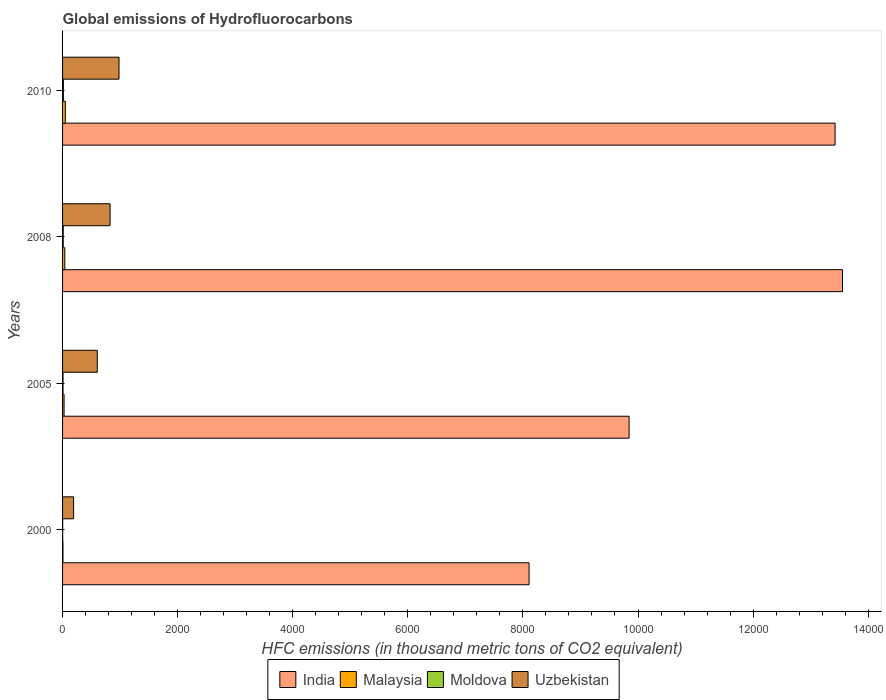How many different coloured bars are there?
Provide a short and direct response. 4. How many groups of bars are there?
Offer a terse response. 4. How many bars are there on the 4th tick from the bottom?
Offer a terse response. 4. What is the label of the 3rd group of bars from the top?
Your response must be concise. 2005. In how many cases, is the number of bars for a given year not equal to the number of legend labels?
Make the answer very short. 0. Across all years, what is the maximum global emissions of Hydrofluorocarbons in Malaysia?
Your response must be concise. 48. Across all years, what is the minimum global emissions of Hydrofluorocarbons in Malaysia?
Offer a very short reply. 6.9. In which year was the global emissions of Hydrofluorocarbons in India minimum?
Your response must be concise. 2000. What is the total global emissions of Hydrofluorocarbons in Moldova in the graph?
Ensure brevity in your answer.  35.2. What is the difference between the global emissions of Hydrofluorocarbons in India in 2005 and the global emissions of Hydrofluorocarbons in Malaysia in 2008?
Provide a succinct answer. 9806. What is the average global emissions of Hydrofluorocarbons in Malaysia per year?
Make the answer very short. 30.05. In the year 2010, what is the difference between the global emissions of Hydrofluorocarbons in Malaysia and global emissions of Hydrofluorocarbons in Uzbekistan?
Ensure brevity in your answer.  -933. In how many years, is the global emissions of Hydrofluorocarbons in India greater than 400 thousand metric tons?
Offer a terse response. 4. What is the ratio of the global emissions of Hydrofluorocarbons in India in 2008 to that in 2010?
Your answer should be compact. 1.01. Is the global emissions of Hydrofluorocarbons in Malaysia in 2008 less than that in 2010?
Keep it short and to the point. Yes. Is the difference between the global emissions of Hydrofluorocarbons in Malaysia in 2000 and 2005 greater than the difference between the global emissions of Hydrofluorocarbons in Uzbekistan in 2000 and 2005?
Offer a very short reply. Yes. What is the difference between the highest and the second highest global emissions of Hydrofluorocarbons in Malaysia?
Provide a short and direct response. 8.8. In how many years, is the global emissions of Hydrofluorocarbons in Malaysia greater than the average global emissions of Hydrofluorocarbons in Malaysia taken over all years?
Keep it short and to the point. 2. Is the sum of the global emissions of Hydrofluorocarbons in Moldova in 2005 and 2010 greater than the maximum global emissions of Hydrofluorocarbons in Malaysia across all years?
Provide a succinct answer. No. What does the 2nd bar from the top in 2008 represents?
Your answer should be compact. Moldova. What does the 3rd bar from the bottom in 2005 represents?
Your answer should be very brief. Moldova. Is it the case that in every year, the sum of the global emissions of Hydrofluorocarbons in Moldova and global emissions of Hydrofluorocarbons in India is greater than the global emissions of Hydrofluorocarbons in Uzbekistan?
Provide a short and direct response. Yes. How many years are there in the graph?
Provide a short and direct response. 4. What is the difference between two consecutive major ticks on the X-axis?
Provide a short and direct response. 2000. Does the graph contain any zero values?
Your answer should be very brief. No. What is the title of the graph?
Offer a very short reply. Global emissions of Hydrofluorocarbons. Does "Spain" appear as one of the legend labels in the graph?
Your response must be concise. No. What is the label or title of the X-axis?
Your answer should be very brief. HFC emissions (in thousand metric tons of CO2 equivalent). What is the label or title of the Y-axis?
Ensure brevity in your answer.  Years. What is the HFC emissions (in thousand metric tons of CO2 equivalent) of India in 2000?
Give a very brief answer. 8107.2. What is the HFC emissions (in thousand metric tons of CO2 equivalent) of Malaysia in 2000?
Your answer should be compact. 6.9. What is the HFC emissions (in thousand metric tons of CO2 equivalent) of Uzbekistan in 2000?
Your response must be concise. 192. What is the HFC emissions (in thousand metric tons of CO2 equivalent) in India in 2005?
Ensure brevity in your answer.  9845.2. What is the HFC emissions (in thousand metric tons of CO2 equivalent) of Malaysia in 2005?
Your response must be concise. 26.1. What is the HFC emissions (in thousand metric tons of CO2 equivalent) of Uzbekistan in 2005?
Keep it short and to the point. 603.2. What is the HFC emissions (in thousand metric tons of CO2 equivalent) of India in 2008?
Give a very brief answer. 1.36e+04. What is the HFC emissions (in thousand metric tons of CO2 equivalent) of Malaysia in 2008?
Provide a succinct answer. 39.2. What is the HFC emissions (in thousand metric tons of CO2 equivalent) of Moldova in 2008?
Make the answer very short. 11.3. What is the HFC emissions (in thousand metric tons of CO2 equivalent) of Uzbekistan in 2008?
Offer a very short reply. 825.6. What is the HFC emissions (in thousand metric tons of CO2 equivalent) of India in 2010?
Keep it short and to the point. 1.34e+04. What is the HFC emissions (in thousand metric tons of CO2 equivalent) of Malaysia in 2010?
Your response must be concise. 48. What is the HFC emissions (in thousand metric tons of CO2 equivalent) of Moldova in 2010?
Offer a very short reply. 14. What is the HFC emissions (in thousand metric tons of CO2 equivalent) of Uzbekistan in 2010?
Offer a very short reply. 981. Across all years, what is the maximum HFC emissions (in thousand metric tons of CO2 equivalent) of India?
Give a very brief answer. 1.36e+04. Across all years, what is the maximum HFC emissions (in thousand metric tons of CO2 equivalent) of Malaysia?
Provide a succinct answer. 48. Across all years, what is the maximum HFC emissions (in thousand metric tons of CO2 equivalent) of Uzbekistan?
Keep it short and to the point. 981. Across all years, what is the minimum HFC emissions (in thousand metric tons of CO2 equivalent) of India?
Provide a short and direct response. 8107.2. Across all years, what is the minimum HFC emissions (in thousand metric tons of CO2 equivalent) of Moldova?
Offer a very short reply. 1.9. Across all years, what is the minimum HFC emissions (in thousand metric tons of CO2 equivalent) of Uzbekistan?
Keep it short and to the point. 192. What is the total HFC emissions (in thousand metric tons of CO2 equivalent) in India in the graph?
Your answer should be very brief. 4.49e+04. What is the total HFC emissions (in thousand metric tons of CO2 equivalent) in Malaysia in the graph?
Your answer should be compact. 120.2. What is the total HFC emissions (in thousand metric tons of CO2 equivalent) in Moldova in the graph?
Your answer should be very brief. 35.2. What is the total HFC emissions (in thousand metric tons of CO2 equivalent) in Uzbekistan in the graph?
Ensure brevity in your answer.  2601.8. What is the difference between the HFC emissions (in thousand metric tons of CO2 equivalent) of India in 2000 and that in 2005?
Give a very brief answer. -1738. What is the difference between the HFC emissions (in thousand metric tons of CO2 equivalent) of Malaysia in 2000 and that in 2005?
Offer a very short reply. -19.2. What is the difference between the HFC emissions (in thousand metric tons of CO2 equivalent) in Moldova in 2000 and that in 2005?
Make the answer very short. -6.1. What is the difference between the HFC emissions (in thousand metric tons of CO2 equivalent) in Uzbekistan in 2000 and that in 2005?
Offer a very short reply. -411.2. What is the difference between the HFC emissions (in thousand metric tons of CO2 equivalent) of India in 2000 and that in 2008?
Your response must be concise. -5446.5. What is the difference between the HFC emissions (in thousand metric tons of CO2 equivalent) in Malaysia in 2000 and that in 2008?
Your answer should be compact. -32.3. What is the difference between the HFC emissions (in thousand metric tons of CO2 equivalent) in Uzbekistan in 2000 and that in 2008?
Offer a very short reply. -633.6. What is the difference between the HFC emissions (in thousand metric tons of CO2 equivalent) in India in 2000 and that in 2010?
Your answer should be very brief. -5317.8. What is the difference between the HFC emissions (in thousand metric tons of CO2 equivalent) in Malaysia in 2000 and that in 2010?
Provide a short and direct response. -41.1. What is the difference between the HFC emissions (in thousand metric tons of CO2 equivalent) of Uzbekistan in 2000 and that in 2010?
Your response must be concise. -789. What is the difference between the HFC emissions (in thousand metric tons of CO2 equivalent) in India in 2005 and that in 2008?
Offer a very short reply. -3708.5. What is the difference between the HFC emissions (in thousand metric tons of CO2 equivalent) in Uzbekistan in 2005 and that in 2008?
Provide a succinct answer. -222.4. What is the difference between the HFC emissions (in thousand metric tons of CO2 equivalent) of India in 2005 and that in 2010?
Provide a succinct answer. -3579.8. What is the difference between the HFC emissions (in thousand metric tons of CO2 equivalent) in Malaysia in 2005 and that in 2010?
Your response must be concise. -21.9. What is the difference between the HFC emissions (in thousand metric tons of CO2 equivalent) of Moldova in 2005 and that in 2010?
Your answer should be very brief. -6. What is the difference between the HFC emissions (in thousand metric tons of CO2 equivalent) in Uzbekistan in 2005 and that in 2010?
Ensure brevity in your answer.  -377.8. What is the difference between the HFC emissions (in thousand metric tons of CO2 equivalent) in India in 2008 and that in 2010?
Your response must be concise. 128.7. What is the difference between the HFC emissions (in thousand metric tons of CO2 equivalent) of Uzbekistan in 2008 and that in 2010?
Provide a short and direct response. -155.4. What is the difference between the HFC emissions (in thousand metric tons of CO2 equivalent) of India in 2000 and the HFC emissions (in thousand metric tons of CO2 equivalent) of Malaysia in 2005?
Offer a terse response. 8081.1. What is the difference between the HFC emissions (in thousand metric tons of CO2 equivalent) of India in 2000 and the HFC emissions (in thousand metric tons of CO2 equivalent) of Moldova in 2005?
Your response must be concise. 8099.2. What is the difference between the HFC emissions (in thousand metric tons of CO2 equivalent) in India in 2000 and the HFC emissions (in thousand metric tons of CO2 equivalent) in Uzbekistan in 2005?
Your answer should be very brief. 7504. What is the difference between the HFC emissions (in thousand metric tons of CO2 equivalent) in Malaysia in 2000 and the HFC emissions (in thousand metric tons of CO2 equivalent) in Uzbekistan in 2005?
Make the answer very short. -596.3. What is the difference between the HFC emissions (in thousand metric tons of CO2 equivalent) of Moldova in 2000 and the HFC emissions (in thousand metric tons of CO2 equivalent) of Uzbekistan in 2005?
Your answer should be compact. -601.3. What is the difference between the HFC emissions (in thousand metric tons of CO2 equivalent) of India in 2000 and the HFC emissions (in thousand metric tons of CO2 equivalent) of Malaysia in 2008?
Keep it short and to the point. 8068. What is the difference between the HFC emissions (in thousand metric tons of CO2 equivalent) in India in 2000 and the HFC emissions (in thousand metric tons of CO2 equivalent) in Moldova in 2008?
Your answer should be very brief. 8095.9. What is the difference between the HFC emissions (in thousand metric tons of CO2 equivalent) of India in 2000 and the HFC emissions (in thousand metric tons of CO2 equivalent) of Uzbekistan in 2008?
Make the answer very short. 7281.6. What is the difference between the HFC emissions (in thousand metric tons of CO2 equivalent) of Malaysia in 2000 and the HFC emissions (in thousand metric tons of CO2 equivalent) of Moldova in 2008?
Offer a terse response. -4.4. What is the difference between the HFC emissions (in thousand metric tons of CO2 equivalent) in Malaysia in 2000 and the HFC emissions (in thousand metric tons of CO2 equivalent) in Uzbekistan in 2008?
Your response must be concise. -818.7. What is the difference between the HFC emissions (in thousand metric tons of CO2 equivalent) in Moldova in 2000 and the HFC emissions (in thousand metric tons of CO2 equivalent) in Uzbekistan in 2008?
Your response must be concise. -823.7. What is the difference between the HFC emissions (in thousand metric tons of CO2 equivalent) in India in 2000 and the HFC emissions (in thousand metric tons of CO2 equivalent) in Malaysia in 2010?
Ensure brevity in your answer.  8059.2. What is the difference between the HFC emissions (in thousand metric tons of CO2 equivalent) in India in 2000 and the HFC emissions (in thousand metric tons of CO2 equivalent) in Moldova in 2010?
Your answer should be very brief. 8093.2. What is the difference between the HFC emissions (in thousand metric tons of CO2 equivalent) in India in 2000 and the HFC emissions (in thousand metric tons of CO2 equivalent) in Uzbekistan in 2010?
Provide a short and direct response. 7126.2. What is the difference between the HFC emissions (in thousand metric tons of CO2 equivalent) of Malaysia in 2000 and the HFC emissions (in thousand metric tons of CO2 equivalent) of Uzbekistan in 2010?
Provide a succinct answer. -974.1. What is the difference between the HFC emissions (in thousand metric tons of CO2 equivalent) in Moldova in 2000 and the HFC emissions (in thousand metric tons of CO2 equivalent) in Uzbekistan in 2010?
Your answer should be compact. -979.1. What is the difference between the HFC emissions (in thousand metric tons of CO2 equivalent) of India in 2005 and the HFC emissions (in thousand metric tons of CO2 equivalent) of Malaysia in 2008?
Offer a very short reply. 9806. What is the difference between the HFC emissions (in thousand metric tons of CO2 equivalent) of India in 2005 and the HFC emissions (in thousand metric tons of CO2 equivalent) of Moldova in 2008?
Make the answer very short. 9833.9. What is the difference between the HFC emissions (in thousand metric tons of CO2 equivalent) of India in 2005 and the HFC emissions (in thousand metric tons of CO2 equivalent) of Uzbekistan in 2008?
Offer a terse response. 9019.6. What is the difference between the HFC emissions (in thousand metric tons of CO2 equivalent) of Malaysia in 2005 and the HFC emissions (in thousand metric tons of CO2 equivalent) of Moldova in 2008?
Offer a terse response. 14.8. What is the difference between the HFC emissions (in thousand metric tons of CO2 equivalent) in Malaysia in 2005 and the HFC emissions (in thousand metric tons of CO2 equivalent) in Uzbekistan in 2008?
Provide a short and direct response. -799.5. What is the difference between the HFC emissions (in thousand metric tons of CO2 equivalent) in Moldova in 2005 and the HFC emissions (in thousand metric tons of CO2 equivalent) in Uzbekistan in 2008?
Offer a very short reply. -817.6. What is the difference between the HFC emissions (in thousand metric tons of CO2 equivalent) of India in 2005 and the HFC emissions (in thousand metric tons of CO2 equivalent) of Malaysia in 2010?
Offer a terse response. 9797.2. What is the difference between the HFC emissions (in thousand metric tons of CO2 equivalent) in India in 2005 and the HFC emissions (in thousand metric tons of CO2 equivalent) in Moldova in 2010?
Provide a succinct answer. 9831.2. What is the difference between the HFC emissions (in thousand metric tons of CO2 equivalent) of India in 2005 and the HFC emissions (in thousand metric tons of CO2 equivalent) of Uzbekistan in 2010?
Your answer should be compact. 8864.2. What is the difference between the HFC emissions (in thousand metric tons of CO2 equivalent) in Malaysia in 2005 and the HFC emissions (in thousand metric tons of CO2 equivalent) in Moldova in 2010?
Your response must be concise. 12.1. What is the difference between the HFC emissions (in thousand metric tons of CO2 equivalent) of Malaysia in 2005 and the HFC emissions (in thousand metric tons of CO2 equivalent) of Uzbekistan in 2010?
Your response must be concise. -954.9. What is the difference between the HFC emissions (in thousand metric tons of CO2 equivalent) of Moldova in 2005 and the HFC emissions (in thousand metric tons of CO2 equivalent) of Uzbekistan in 2010?
Keep it short and to the point. -973. What is the difference between the HFC emissions (in thousand metric tons of CO2 equivalent) in India in 2008 and the HFC emissions (in thousand metric tons of CO2 equivalent) in Malaysia in 2010?
Give a very brief answer. 1.35e+04. What is the difference between the HFC emissions (in thousand metric tons of CO2 equivalent) in India in 2008 and the HFC emissions (in thousand metric tons of CO2 equivalent) in Moldova in 2010?
Your answer should be compact. 1.35e+04. What is the difference between the HFC emissions (in thousand metric tons of CO2 equivalent) of India in 2008 and the HFC emissions (in thousand metric tons of CO2 equivalent) of Uzbekistan in 2010?
Make the answer very short. 1.26e+04. What is the difference between the HFC emissions (in thousand metric tons of CO2 equivalent) in Malaysia in 2008 and the HFC emissions (in thousand metric tons of CO2 equivalent) in Moldova in 2010?
Your answer should be very brief. 25.2. What is the difference between the HFC emissions (in thousand metric tons of CO2 equivalent) in Malaysia in 2008 and the HFC emissions (in thousand metric tons of CO2 equivalent) in Uzbekistan in 2010?
Ensure brevity in your answer.  -941.8. What is the difference between the HFC emissions (in thousand metric tons of CO2 equivalent) in Moldova in 2008 and the HFC emissions (in thousand metric tons of CO2 equivalent) in Uzbekistan in 2010?
Provide a short and direct response. -969.7. What is the average HFC emissions (in thousand metric tons of CO2 equivalent) of India per year?
Keep it short and to the point. 1.12e+04. What is the average HFC emissions (in thousand metric tons of CO2 equivalent) in Malaysia per year?
Your answer should be very brief. 30.05. What is the average HFC emissions (in thousand metric tons of CO2 equivalent) in Moldova per year?
Your response must be concise. 8.8. What is the average HFC emissions (in thousand metric tons of CO2 equivalent) in Uzbekistan per year?
Your answer should be compact. 650.45. In the year 2000, what is the difference between the HFC emissions (in thousand metric tons of CO2 equivalent) in India and HFC emissions (in thousand metric tons of CO2 equivalent) in Malaysia?
Make the answer very short. 8100.3. In the year 2000, what is the difference between the HFC emissions (in thousand metric tons of CO2 equivalent) in India and HFC emissions (in thousand metric tons of CO2 equivalent) in Moldova?
Your answer should be very brief. 8105.3. In the year 2000, what is the difference between the HFC emissions (in thousand metric tons of CO2 equivalent) in India and HFC emissions (in thousand metric tons of CO2 equivalent) in Uzbekistan?
Keep it short and to the point. 7915.2. In the year 2000, what is the difference between the HFC emissions (in thousand metric tons of CO2 equivalent) in Malaysia and HFC emissions (in thousand metric tons of CO2 equivalent) in Moldova?
Ensure brevity in your answer.  5. In the year 2000, what is the difference between the HFC emissions (in thousand metric tons of CO2 equivalent) in Malaysia and HFC emissions (in thousand metric tons of CO2 equivalent) in Uzbekistan?
Offer a terse response. -185.1. In the year 2000, what is the difference between the HFC emissions (in thousand metric tons of CO2 equivalent) of Moldova and HFC emissions (in thousand metric tons of CO2 equivalent) of Uzbekistan?
Provide a succinct answer. -190.1. In the year 2005, what is the difference between the HFC emissions (in thousand metric tons of CO2 equivalent) in India and HFC emissions (in thousand metric tons of CO2 equivalent) in Malaysia?
Your answer should be compact. 9819.1. In the year 2005, what is the difference between the HFC emissions (in thousand metric tons of CO2 equivalent) of India and HFC emissions (in thousand metric tons of CO2 equivalent) of Moldova?
Give a very brief answer. 9837.2. In the year 2005, what is the difference between the HFC emissions (in thousand metric tons of CO2 equivalent) in India and HFC emissions (in thousand metric tons of CO2 equivalent) in Uzbekistan?
Provide a short and direct response. 9242. In the year 2005, what is the difference between the HFC emissions (in thousand metric tons of CO2 equivalent) of Malaysia and HFC emissions (in thousand metric tons of CO2 equivalent) of Uzbekistan?
Make the answer very short. -577.1. In the year 2005, what is the difference between the HFC emissions (in thousand metric tons of CO2 equivalent) in Moldova and HFC emissions (in thousand metric tons of CO2 equivalent) in Uzbekistan?
Provide a short and direct response. -595.2. In the year 2008, what is the difference between the HFC emissions (in thousand metric tons of CO2 equivalent) in India and HFC emissions (in thousand metric tons of CO2 equivalent) in Malaysia?
Provide a short and direct response. 1.35e+04. In the year 2008, what is the difference between the HFC emissions (in thousand metric tons of CO2 equivalent) of India and HFC emissions (in thousand metric tons of CO2 equivalent) of Moldova?
Your answer should be compact. 1.35e+04. In the year 2008, what is the difference between the HFC emissions (in thousand metric tons of CO2 equivalent) of India and HFC emissions (in thousand metric tons of CO2 equivalent) of Uzbekistan?
Your answer should be very brief. 1.27e+04. In the year 2008, what is the difference between the HFC emissions (in thousand metric tons of CO2 equivalent) of Malaysia and HFC emissions (in thousand metric tons of CO2 equivalent) of Moldova?
Offer a terse response. 27.9. In the year 2008, what is the difference between the HFC emissions (in thousand metric tons of CO2 equivalent) in Malaysia and HFC emissions (in thousand metric tons of CO2 equivalent) in Uzbekistan?
Your answer should be very brief. -786.4. In the year 2008, what is the difference between the HFC emissions (in thousand metric tons of CO2 equivalent) of Moldova and HFC emissions (in thousand metric tons of CO2 equivalent) of Uzbekistan?
Offer a very short reply. -814.3. In the year 2010, what is the difference between the HFC emissions (in thousand metric tons of CO2 equivalent) in India and HFC emissions (in thousand metric tons of CO2 equivalent) in Malaysia?
Ensure brevity in your answer.  1.34e+04. In the year 2010, what is the difference between the HFC emissions (in thousand metric tons of CO2 equivalent) of India and HFC emissions (in thousand metric tons of CO2 equivalent) of Moldova?
Ensure brevity in your answer.  1.34e+04. In the year 2010, what is the difference between the HFC emissions (in thousand metric tons of CO2 equivalent) of India and HFC emissions (in thousand metric tons of CO2 equivalent) of Uzbekistan?
Keep it short and to the point. 1.24e+04. In the year 2010, what is the difference between the HFC emissions (in thousand metric tons of CO2 equivalent) in Malaysia and HFC emissions (in thousand metric tons of CO2 equivalent) in Uzbekistan?
Give a very brief answer. -933. In the year 2010, what is the difference between the HFC emissions (in thousand metric tons of CO2 equivalent) of Moldova and HFC emissions (in thousand metric tons of CO2 equivalent) of Uzbekistan?
Your answer should be compact. -967. What is the ratio of the HFC emissions (in thousand metric tons of CO2 equivalent) in India in 2000 to that in 2005?
Your response must be concise. 0.82. What is the ratio of the HFC emissions (in thousand metric tons of CO2 equivalent) of Malaysia in 2000 to that in 2005?
Give a very brief answer. 0.26. What is the ratio of the HFC emissions (in thousand metric tons of CO2 equivalent) in Moldova in 2000 to that in 2005?
Your answer should be very brief. 0.24. What is the ratio of the HFC emissions (in thousand metric tons of CO2 equivalent) of Uzbekistan in 2000 to that in 2005?
Make the answer very short. 0.32. What is the ratio of the HFC emissions (in thousand metric tons of CO2 equivalent) in India in 2000 to that in 2008?
Make the answer very short. 0.6. What is the ratio of the HFC emissions (in thousand metric tons of CO2 equivalent) in Malaysia in 2000 to that in 2008?
Offer a terse response. 0.18. What is the ratio of the HFC emissions (in thousand metric tons of CO2 equivalent) of Moldova in 2000 to that in 2008?
Your response must be concise. 0.17. What is the ratio of the HFC emissions (in thousand metric tons of CO2 equivalent) of Uzbekistan in 2000 to that in 2008?
Provide a succinct answer. 0.23. What is the ratio of the HFC emissions (in thousand metric tons of CO2 equivalent) in India in 2000 to that in 2010?
Your answer should be very brief. 0.6. What is the ratio of the HFC emissions (in thousand metric tons of CO2 equivalent) of Malaysia in 2000 to that in 2010?
Your answer should be very brief. 0.14. What is the ratio of the HFC emissions (in thousand metric tons of CO2 equivalent) of Moldova in 2000 to that in 2010?
Your answer should be compact. 0.14. What is the ratio of the HFC emissions (in thousand metric tons of CO2 equivalent) in Uzbekistan in 2000 to that in 2010?
Ensure brevity in your answer.  0.2. What is the ratio of the HFC emissions (in thousand metric tons of CO2 equivalent) in India in 2005 to that in 2008?
Give a very brief answer. 0.73. What is the ratio of the HFC emissions (in thousand metric tons of CO2 equivalent) in Malaysia in 2005 to that in 2008?
Your response must be concise. 0.67. What is the ratio of the HFC emissions (in thousand metric tons of CO2 equivalent) of Moldova in 2005 to that in 2008?
Ensure brevity in your answer.  0.71. What is the ratio of the HFC emissions (in thousand metric tons of CO2 equivalent) of Uzbekistan in 2005 to that in 2008?
Give a very brief answer. 0.73. What is the ratio of the HFC emissions (in thousand metric tons of CO2 equivalent) of India in 2005 to that in 2010?
Offer a very short reply. 0.73. What is the ratio of the HFC emissions (in thousand metric tons of CO2 equivalent) in Malaysia in 2005 to that in 2010?
Your answer should be compact. 0.54. What is the ratio of the HFC emissions (in thousand metric tons of CO2 equivalent) of Uzbekistan in 2005 to that in 2010?
Offer a very short reply. 0.61. What is the ratio of the HFC emissions (in thousand metric tons of CO2 equivalent) in India in 2008 to that in 2010?
Offer a terse response. 1.01. What is the ratio of the HFC emissions (in thousand metric tons of CO2 equivalent) of Malaysia in 2008 to that in 2010?
Your answer should be very brief. 0.82. What is the ratio of the HFC emissions (in thousand metric tons of CO2 equivalent) of Moldova in 2008 to that in 2010?
Give a very brief answer. 0.81. What is the ratio of the HFC emissions (in thousand metric tons of CO2 equivalent) in Uzbekistan in 2008 to that in 2010?
Make the answer very short. 0.84. What is the difference between the highest and the second highest HFC emissions (in thousand metric tons of CO2 equivalent) in India?
Offer a terse response. 128.7. What is the difference between the highest and the second highest HFC emissions (in thousand metric tons of CO2 equivalent) of Uzbekistan?
Give a very brief answer. 155.4. What is the difference between the highest and the lowest HFC emissions (in thousand metric tons of CO2 equivalent) of India?
Offer a very short reply. 5446.5. What is the difference between the highest and the lowest HFC emissions (in thousand metric tons of CO2 equivalent) of Malaysia?
Ensure brevity in your answer.  41.1. What is the difference between the highest and the lowest HFC emissions (in thousand metric tons of CO2 equivalent) of Moldova?
Provide a succinct answer. 12.1. What is the difference between the highest and the lowest HFC emissions (in thousand metric tons of CO2 equivalent) of Uzbekistan?
Provide a short and direct response. 789. 